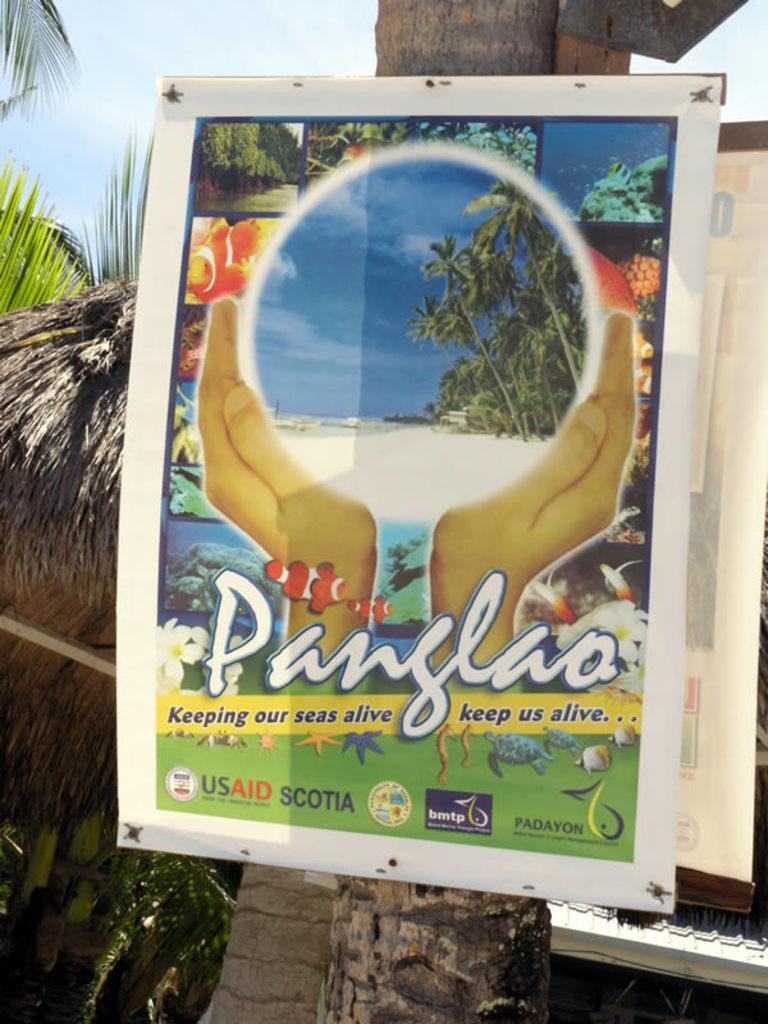Can you describe this image briefly? In this image we can see a poster on the tree trunk. In the background of the image there is sky. 